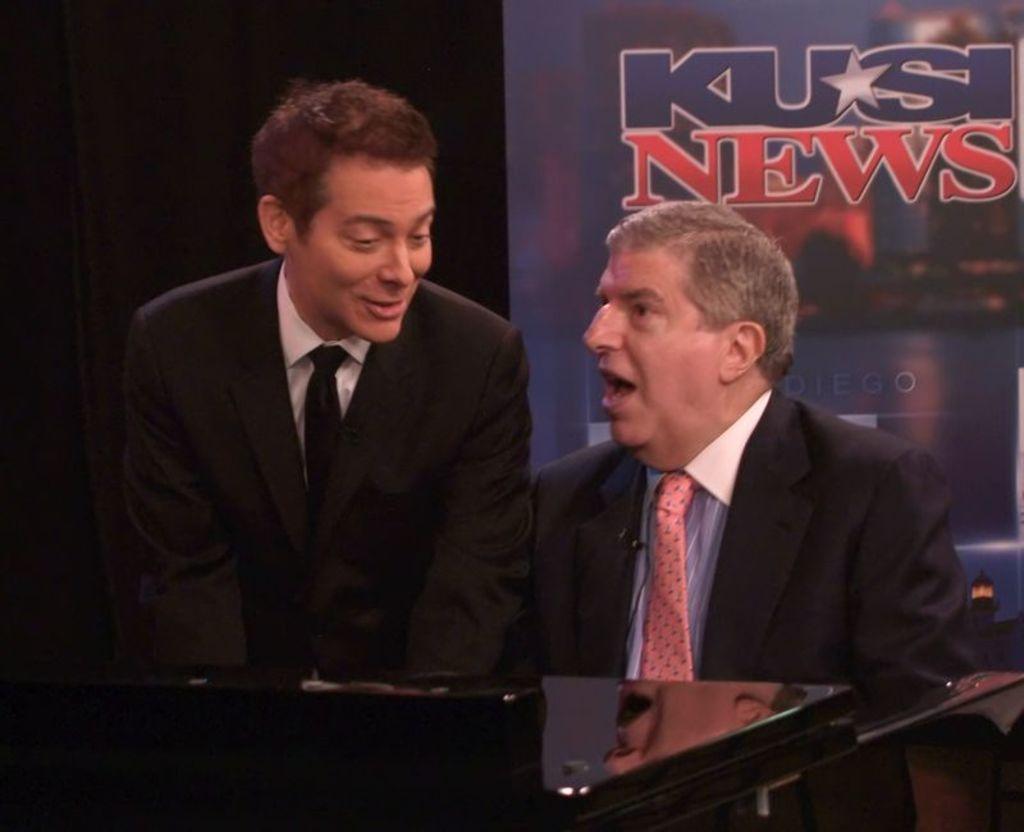Can you describe this image briefly? This picture shows a man seated and we see another man standing on the side and we see a advertisement board on the back, Both of them wore coats and we see a table. 